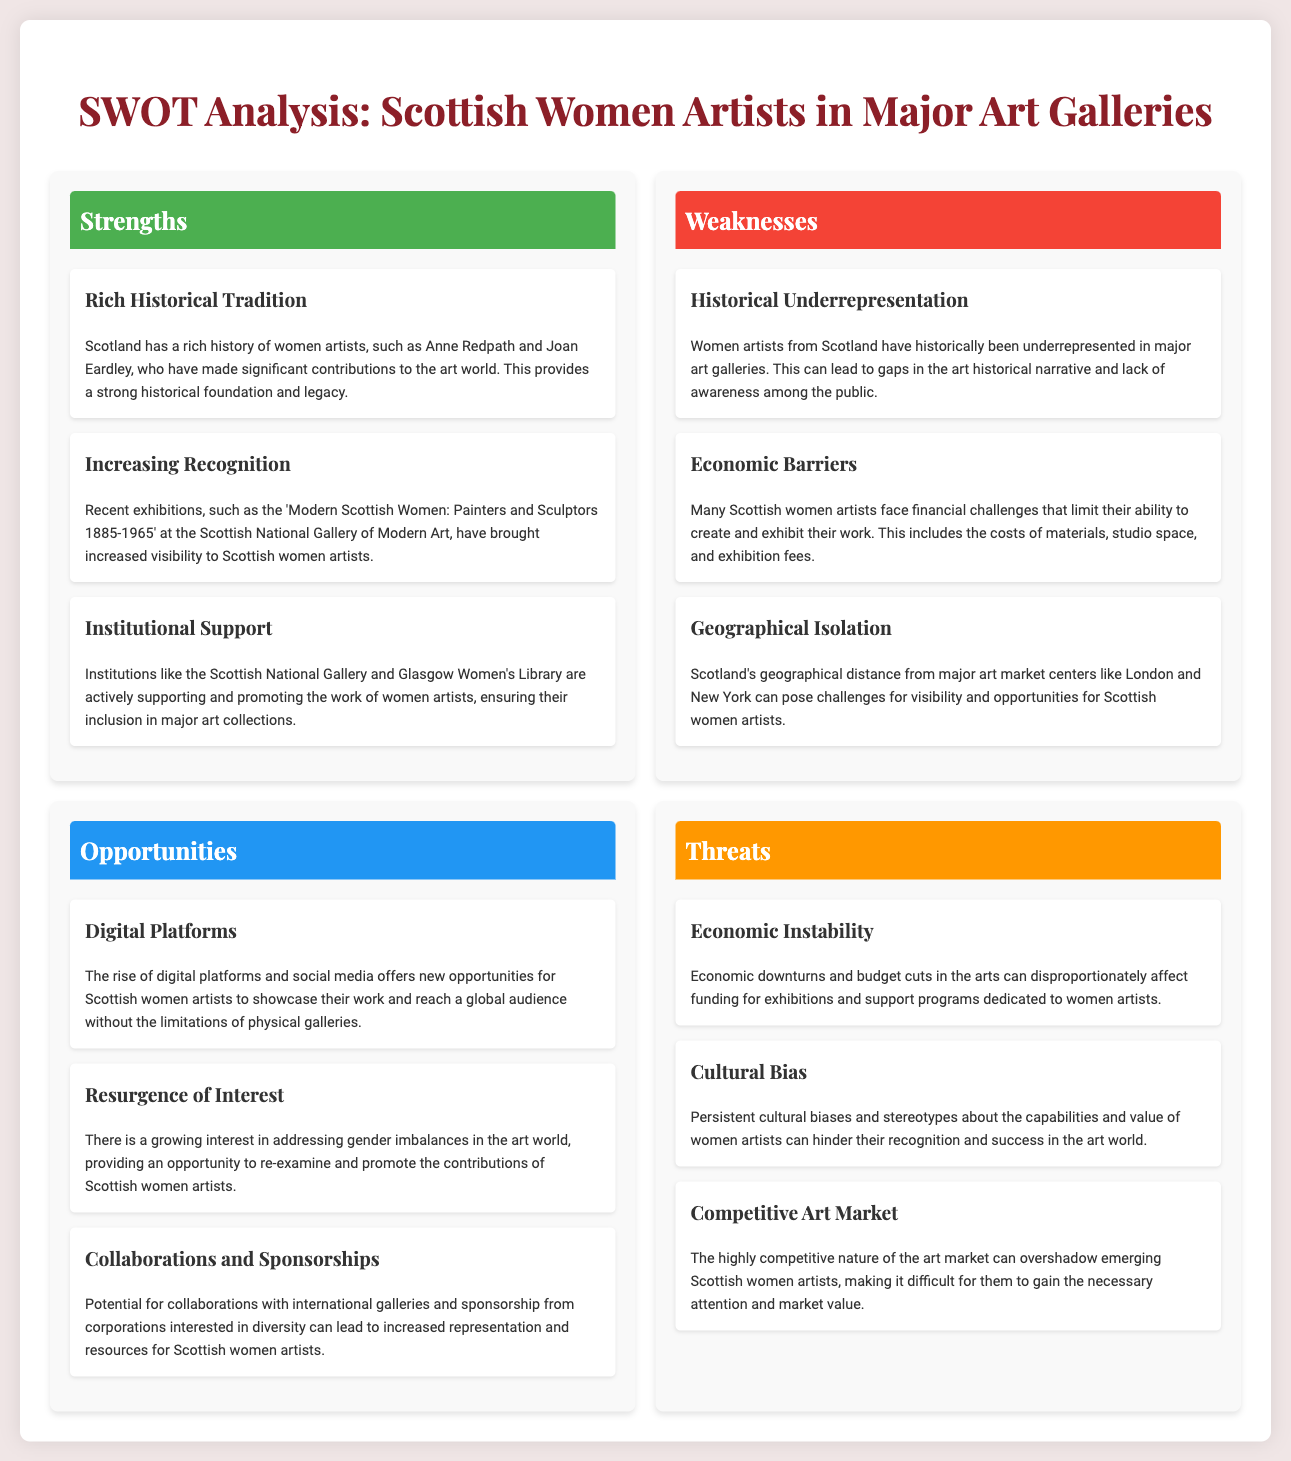What is a key strength mentioned for Scottish women artists? The document lists "Rich Historical Tradition" as a specific strength highlighting the contributions of artists like Anne Redpath and Joan Eardley.
Answer: Rich Historical Tradition What exhibition increased visibility for Scottish women artists? The SWOT analysis mentions the exhibition titled "Modern Scottish Women: Painters and Sculptors 1885-1965" as a significant event for recognition.
Answer: Modern Scottish Women: Painters and Sculptors 1885-1965 What is one of the weaknesses related to economic barriers? The analysis states that many Scottish women artists face financial challenges that limit their ability to create and exhibit their work.
Answer: Financial challenges What opportunity is associated with digital platforms? The rise of digital platforms and social media is identified as an opportunity for artists to showcase their work globally.
Answer: Showcase their work globally What threat is mentioned regarding economic conditions? The document identifies "Economic Instability" as a threat that can affect funding for exhibitions and programs for women artists.
Answer: Economic Instability What type of bias threatens women artists? The document refers to "Cultural Bias" as a persistent threat that can hinder recognition and success in the art world.
Answer: Cultural Bias How many strengths are listed in the SWOT analysis? The strengths section contains three specific items highlighting various aspects of support for women artists.
Answer: Three What geographical challenge do Scottish women artists face? The document mentions "Geographical Isolation" as a challenge impacting visibility and opportunities.
Answer: Geographical Isolation What is the primary focus of this document? The SWOT analysis centers on the representation of Scottish women artists in major art galleries.
Answer: Representation of Scottish women artists 